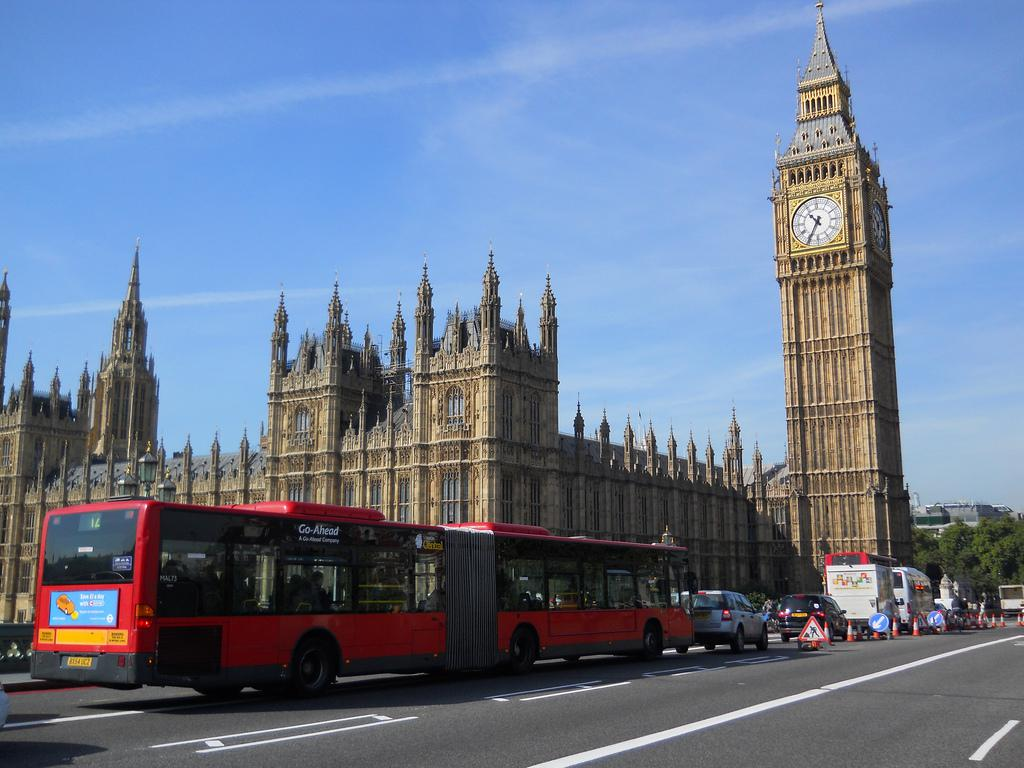Question: what famous clock is this?
Choices:
A. The Grand Central Terminal Clock.
B. Glockenspiel.
C. Cosmo Clock 21.
D. Big ben.
Answer with the letter. Answer: D Question: what type of day is it in london?
Choices:
A. A stormy gray day.
B. A warm and breezy day.
C. A bright sunny day.
D. A gray and cool day.
Answer with the letter. Answer: C Question: what stands over a red tour bus on a busy street in london?
Choices:
A. Big ben.
B. A building.
C. A light.
D. A tree.
Answer with the letter. Answer: A Question: what is all going in the same direction?
Choices:
A. Traffic.
B. People.
C. Birds.
D. Bees.
Answer with the letter. Answer: A Question: what color markings are on the street?
Choices:
A. Red.
B. Blue.
C. Black.
D. White.
Answer with the letter. Answer: D Question: what color extender bus is rolling down the streets?
Choices:
A. Black.
B. Yellow.
C. Silver.
D. Red.
Answer with the letter. Answer: D Question: what popular tourist destination are the buses driving by?
Choices:
A. Buckingham palace.
B. A monument.
C. Big ben.
D. The museum.
Answer with the letter. Answer: C Question: where are there trace clouds?
Choices:
A. To the left.
B. In the sky.
C. To the right.
D. In the air.
Answer with the letter. Answer: B Question: why are the cars stopped?
Choices:
A. It is a red light.
B. There is a stop sign.
C. There is an accident.
D. There are caution signs.
Answer with the letter. Answer: D Question: when is the photo taken?
Choices:
A. At night.
B. In the afternoon.
C. In the morning.
D. During the day.
Answer with the letter. Answer: D Question: what large vehicle is in the foreground?
Choices:
A. A bus.
B. A tank.
C. A police van.
D. A truck.
Answer with the letter. Answer: A Question: where is this clock located?
Choices:
A. Yokohama, Japan.
B. Munich, Germany.
C. London, england.
D. New York, United States.
Answer with the letter. Answer: C Question: what colors are on the clock?
Choices:
A. Green and yellow.
B. White and black.
C. Red and blue.
D. Black and gray.
Answer with the letter. Answer: B Question: what buildings have spires on them?
Choices:
A. The churches.
B. The surrounding ones.
C. The ones on the left.
D. The tall ones.
Answer with the letter. Answer: B Question: what do the clock tower and attached buildings have?
Choices:
A. Towers.
B. Weathervanes.
C. Spires.
D. Flat roofs.
Answer with the letter. Answer: C Question: what reads 10:35?
Choices:
A. The DVD player.
B. The iPhone.
C. The microwave.
D. The clock.
Answer with the letter. Answer: D Question: what lines the street?
Choices:
A. Parade watchers.
B. Traffic cones.
C. Trees.
D. Flowers.
Answer with the letter. Answer: B 